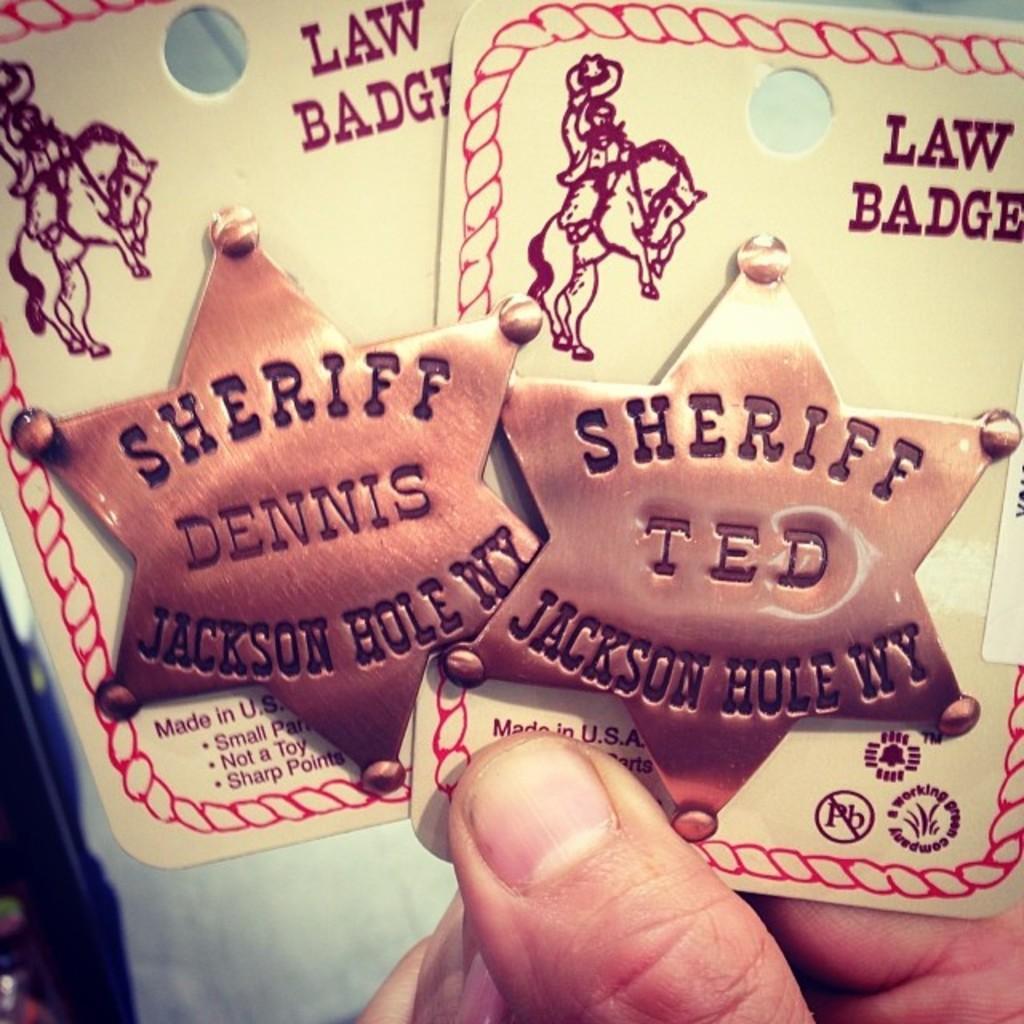Can you describe this image briefly? In this image I can see fingers of a person and I can see this person is holding two white colour things. I can also see something is written on these things. 